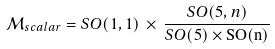<formula> <loc_0><loc_0><loc_500><loc_500>\mathcal { M } _ { s c a l a r } = S O ( 1 , 1 ) \, \times \, \frac { S O ( 5 , n ) } { S O ( 5 ) \times \mathrm { S O ( n ) } }</formula> 